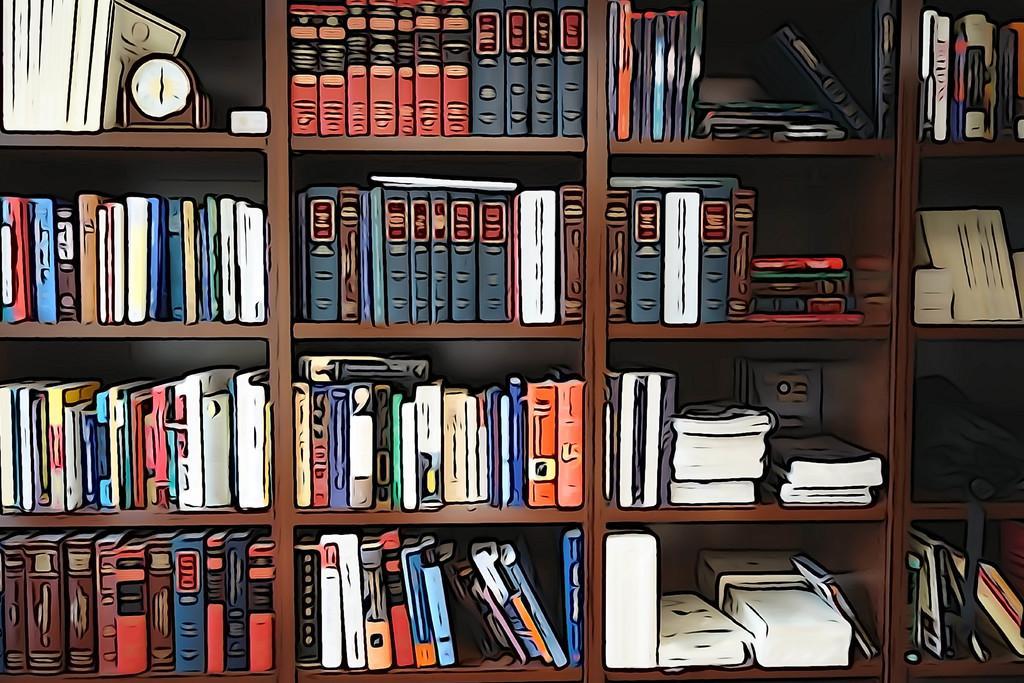Could you give a brief overview of what you see in this image? It is an edited image. In this image there are books and a clock in a wooden shelves. 